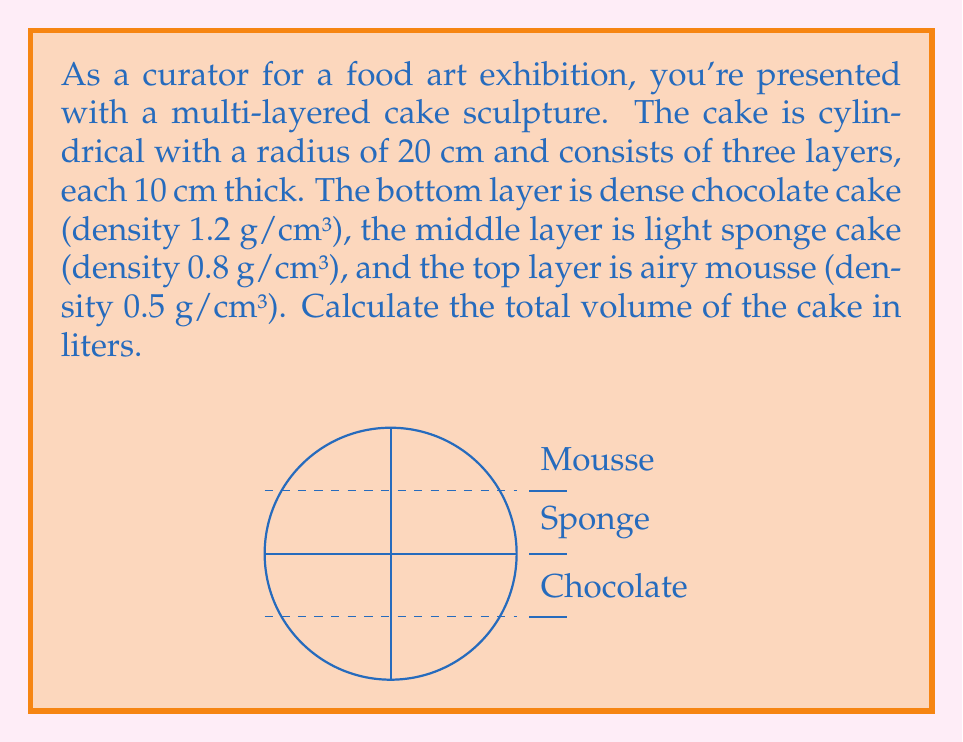Provide a solution to this math problem. To solve this problem, we'll follow these steps:

1) First, let's recall the formula for the volume of a cylinder:
   $$V = \pi r^2 h$$
   where $r$ is the radius and $h$ is the height.

2) We're given that the radius is 20 cm and each layer is 10 cm thick. The total height of the cake is 30 cm (3 layers * 10 cm).

3) Let's calculate the volume of the entire cake:
   $$V = \pi (20 \text{ cm})^2 (30 \text{ cm}) = 37,699.11 \text{ cm}^3$$

4) Now, we need to convert this to liters. We know that 1 liter = 1000 cm³, so:
   $$37,699.11 \text{ cm}^3 * \frac{1 \text{ L}}{1000 \text{ cm}^3} = 37.69911 \text{ L}$$

5) Rounding to two decimal places for practicality:
   $$V \approx 37.70 \text{ L}$$

Note: The varying densities of the layers don't affect the volume calculation, but they would be relevant if we were calculating the mass of the cake.
Answer: 37.70 L 